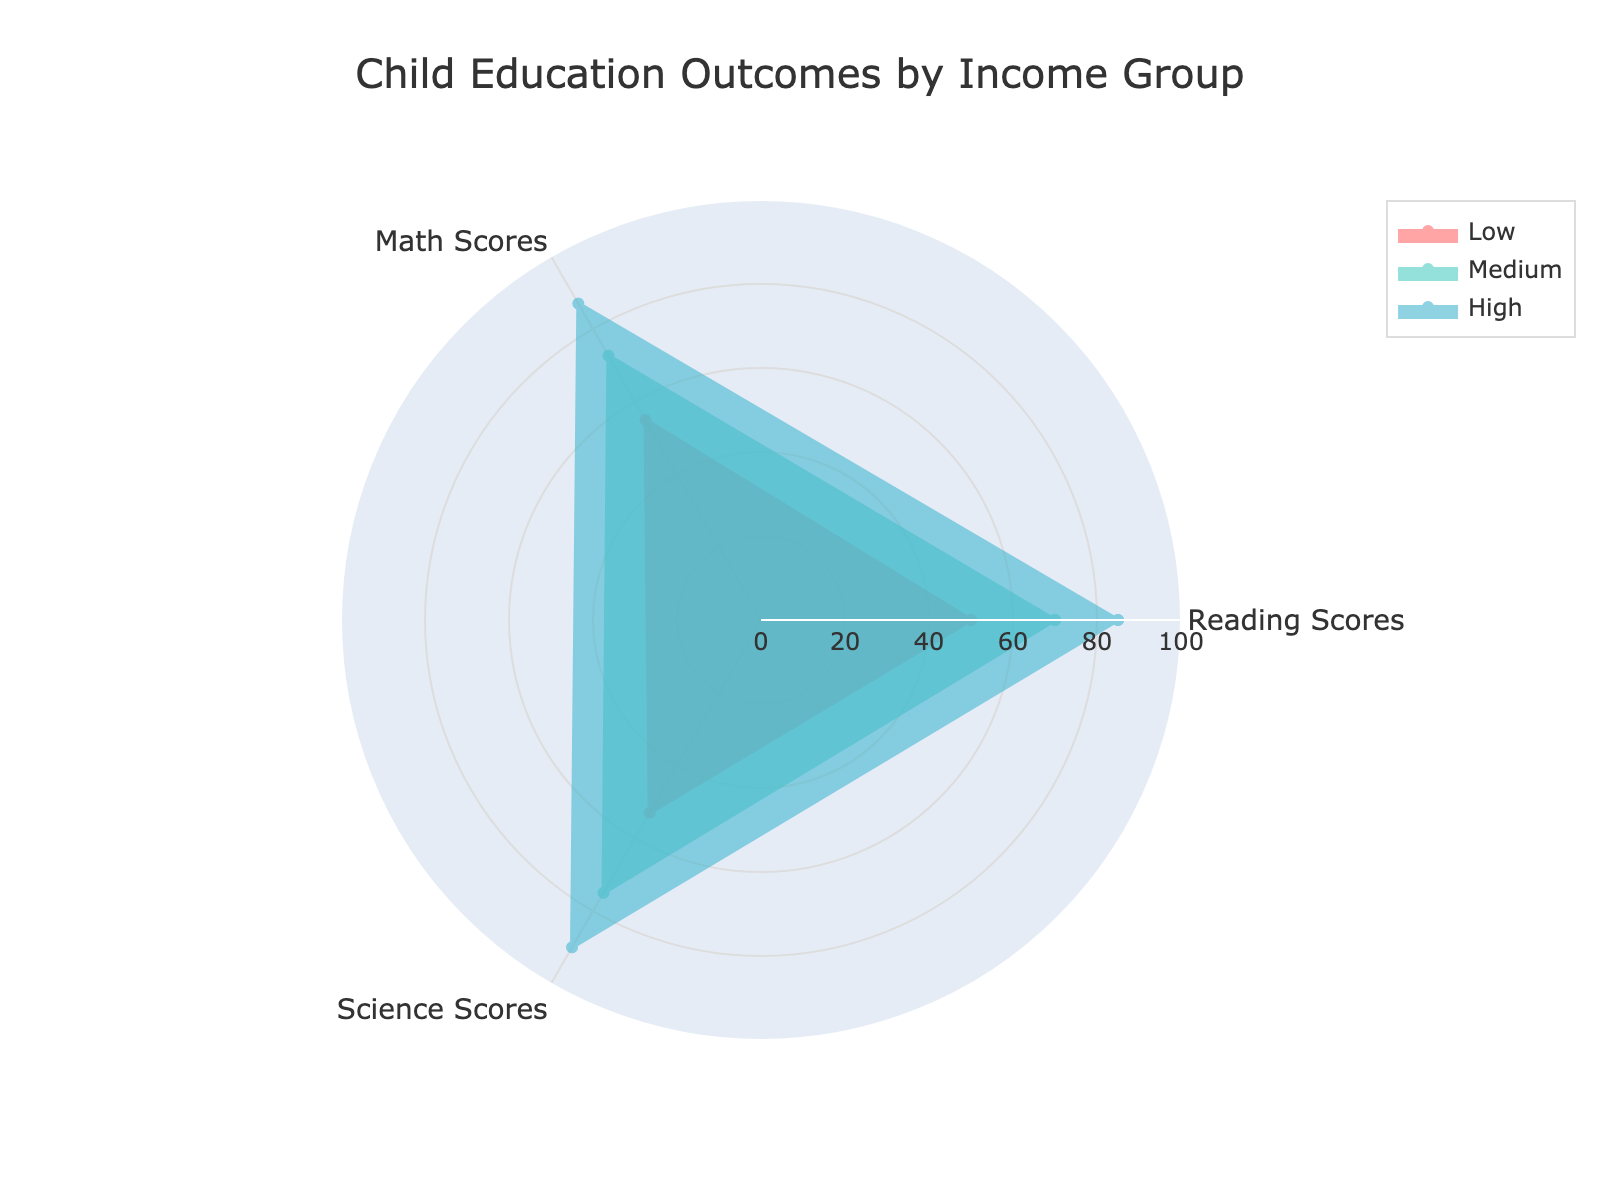What is the title of the radar chart? The title is commonly placed at the top of the chart and should provide an overall description of what the chart is about.
Answer: Child Education Outcomes by Income Group Which income group has the highest average scores across all subjects? The group with the highest average scores across all subjects will have the largest area within the radar chart. By visually inspecting, the 'High' income group has the highest average scores.
Answer: High What is the range of values for the radial axis? The radial axis range can be seen from the chart's radial lines, the outermost line defines the maximum value and the innermost line defines the minimum value.
Answer: 0 to 100 How do reading scores for the 'Medium' income group compare to science scores for the same group? To compare these scores, look at the plot points or line extensions for reading scores and science scores for the 'Medium' income group on the radar chart. Both appear to be quite close but science scores are slightly higher.
Answer: Science scores are higher Which subject shows the largest performance difference between the 'Low' and 'High' income groups? This question requires comparing the gap between points for 'Low' and 'High' income groups on each of the subject axes, the largest difference is visually apparent. Reading Scores have the largest difference.
Answer: Reading Scores What is the average math score for the High income group? Add up the math scores for full, limited, and no access to extracurricular activities within the 'High' income group and then divide by 3 to get the average. (92 + 87 + 82)/3
Answer: 87 Do extracurricular activities influence the child education outcomes differently depending on the income group? This question necessitates a comparative analysis of radar sections for various extracurricular levels (none, limited, full) within each income group, with clear visible distinctions seen on the radar chart. Yes, higher access to extracurricular activities generally boosts scores regardless of income group but with more pronounced effects in 'Low' and 'Medium' income groups.
Answer: Yes How does parent education level seem to impact child outcomes among the income groups? Consider the mean scores for each income group, taking note of the parent education level associated with each group. Overall, higher parent education levels correspond with higher child education outcomes visible across all subjects.
Answer: Higher education levels of parents correlate with better scores 